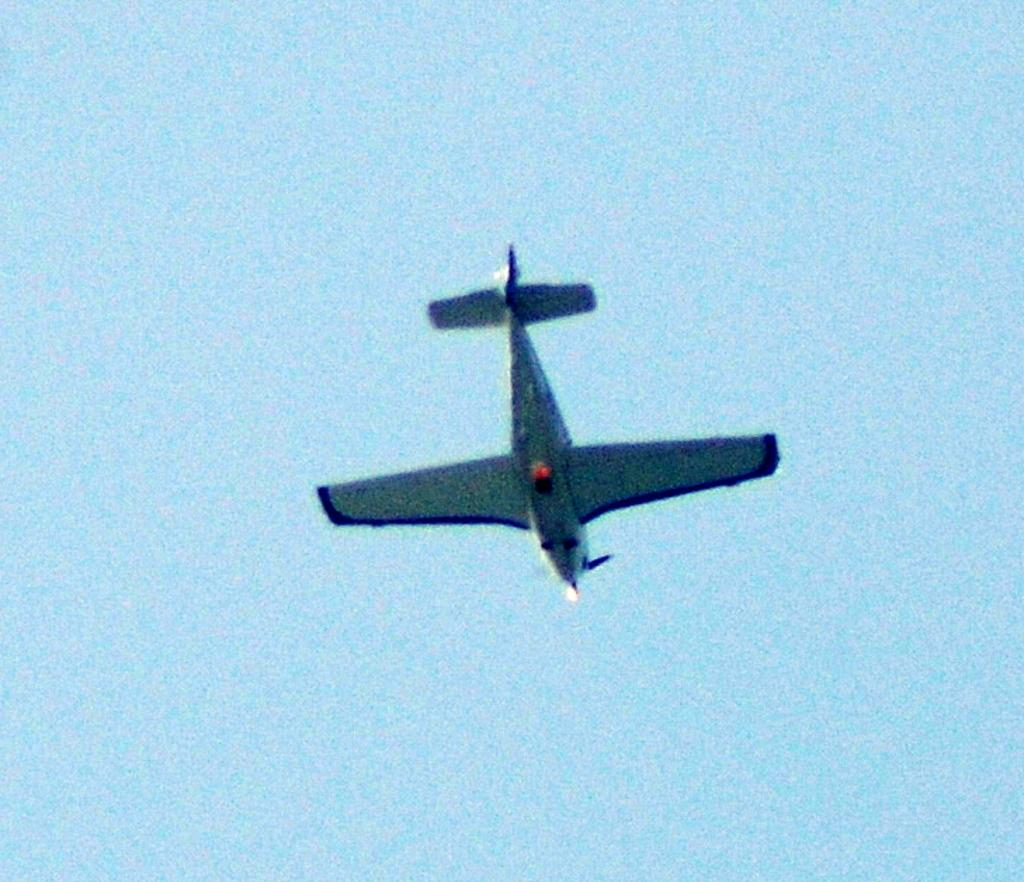What is the main subject of the image? The main subject of the image is an airplane. What is the airplane doing in the image? The airplane is flying in the air. What color is the airplane? The airplane is navy blue in color. What can be seen in the background of the image? The sky is visible in the image. What is the color of the sky? The sky is blue. Can you see any twigs or branches in the image? No, there are no twigs or branches present in the image. Is there a ball visible in the image? No, there is no ball visible in the image. 